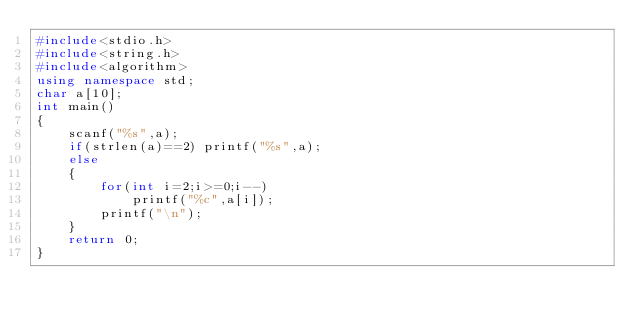<code> <loc_0><loc_0><loc_500><loc_500><_C++_>#include<stdio.h>
#include<string.h>
#include<algorithm>
using namespace std;
char a[10];
int main()
{
    scanf("%s",a);
    if(strlen(a)==2) printf("%s",a);
    else
    {
        for(int i=2;i>=0;i--)
            printf("%c",a[i]);
        printf("\n");
    }
    return 0;
}
</code> 